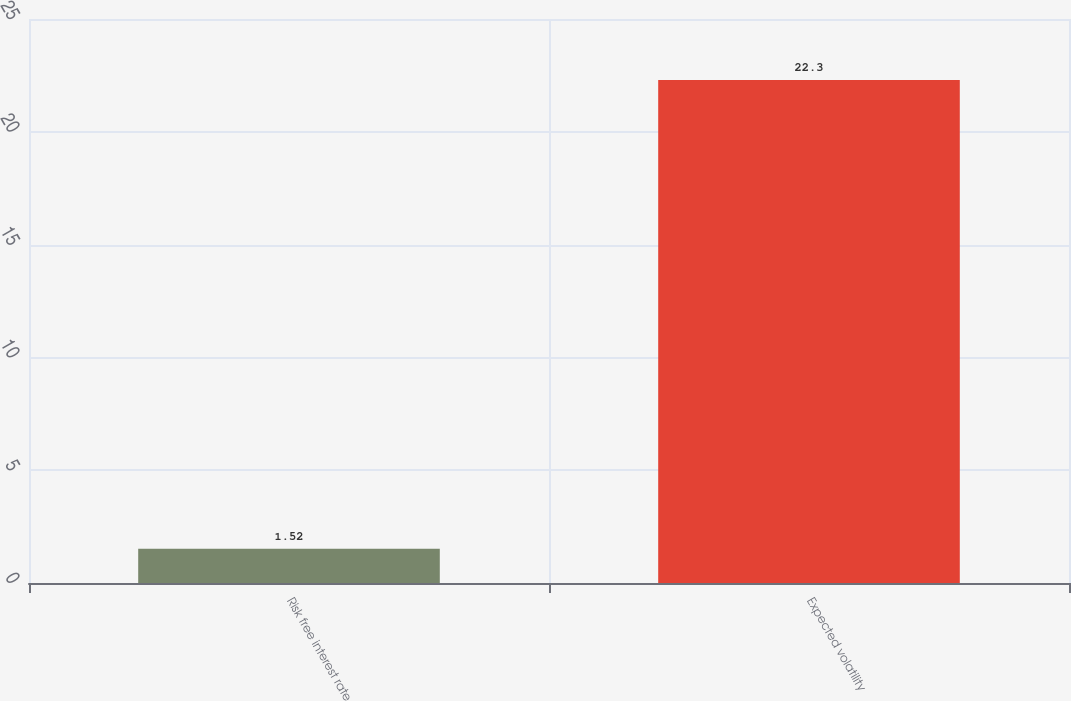Convert chart to OTSL. <chart><loc_0><loc_0><loc_500><loc_500><bar_chart><fcel>Risk free interest rate<fcel>Expected volatility<nl><fcel>1.52<fcel>22.3<nl></chart> 